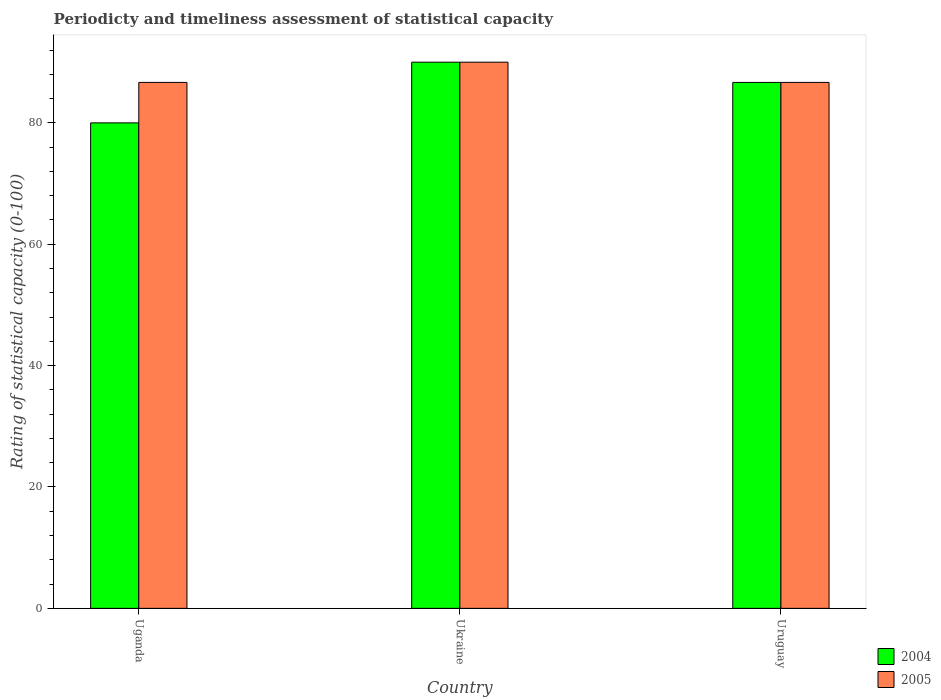Are the number of bars per tick equal to the number of legend labels?
Offer a very short reply. Yes. Are the number of bars on each tick of the X-axis equal?
Provide a succinct answer. Yes. How many bars are there on the 3rd tick from the right?
Offer a very short reply. 2. What is the label of the 1st group of bars from the left?
Ensure brevity in your answer.  Uganda. In how many cases, is the number of bars for a given country not equal to the number of legend labels?
Your answer should be compact. 0. What is the rating of statistical capacity in 2005 in Ukraine?
Your response must be concise. 90. Across all countries, what is the maximum rating of statistical capacity in 2004?
Provide a short and direct response. 90. In which country was the rating of statistical capacity in 2005 maximum?
Your answer should be very brief. Ukraine. In which country was the rating of statistical capacity in 2005 minimum?
Ensure brevity in your answer.  Uganda. What is the total rating of statistical capacity in 2004 in the graph?
Offer a terse response. 256.67. What is the difference between the rating of statistical capacity in 2005 in Uganda and that in Ukraine?
Your response must be concise. -3.33. What is the difference between the rating of statistical capacity in 2005 in Uganda and the rating of statistical capacity in 2004 in Uruguay?
Make the answer very short. 0. What is the average rating of statistical capacity in 2004 per country?
Provide a short and direct response. 85.56. What is the difference between the rating of statistical capacity of/in 2004 and rating of statistical capacity of/in 2005 in Uruguay?
Offer a terse response. 0. What is the ratio of the rating of statistical capacity in 2005 in Uganda to that in Ukraine?
Your answer should be compact. 0.96. What is the difference between the highest and the second highest rating of statistical capacity in 2004?
Your answer should be compact. -10. What is the difference between the highest and the lowest rating of statistical capacity in 2005?
Your answer should be very brief. 3.33. Is the sum of the rating of statistical capacity in 2004 in Uganda and Ukraine greater than the maximum rating of statistical capacity in 2005 across all countries?
Provide a succinct answer. Yes. What does the 2nd bar from the right in Uruguay represents?
Keep it short and to the point. 2004. How many bars are there?
Provide a short and direct response. 6. How many countries are there in the graph?
Give a very brief answer. 3. Where does the legend appear in the graph?
Give a very brief answer. Bottom right. How many legend labels are there?
Give a very brief answer. 2. How are the legend labels stacked?
Keep it short and to the point. Vertical. What is the title of the graph?
Keep it short and to the point. Periodicty and timeliness assessment of statistical capacity. Does "2000" appear as one of the legend labels in the graph?
Ensure brevity in your answer.  No. What is the label or title of the Y-axis?
Keep it short and to the point. Rating of statistical capacity (0-100). What is the Rating of statistical capacity (0-100) of 2004 in Uganda?
Offer a terse response. 80. What is the Rating of statistical capacity (0-100) of 2005 in Uganda?
Your answer should be very brief. 86.67. What is the Rating of statistical capacity (0-100) in 2005 in Ukraine?
Ensure brevity in your answer.  90. What is the Rating of statistical capacity (0-100) of 2004 in Uruguay?
Ensure brevity in your answer.  86.67. What is the Rating of statistical capacity (0-100) of 2005 in Uruguay?
Your answer should be compact. 86.67. Across all countries, what is the maximum Rating of statistical capacity (0-100) in 2004?
Give a very brief answer. 90. Across all countries, what is the maximum Rating of statistical capacity (0-100) of 2005?
Offer a very short reply. 90. Across all countries, what is the minimum Rating of statistical capacity (0-100) of 2005?
Your answer should be compact. 86.67. What is the total Rating of statistical capacity (0-100) in 2004 in the graph?
Your answer should be compact. 256.67. What is the total Rating of statistical capacity (0-100) in 2005 in the graph?
Provide a short and direct response. 263.33. What is the difference between the Rating of statistical capacity (0-100) in 2005 in Uganda and that in Ukraine?
Offer a terse response. -3.33. What is the difference between the Rating of statistical capacity (0-100) of 2004 in Uganda and that in Uruguay?
Ensure brevity in your answer.  -6.67. What is the difference between the Rating of statistical capacity (0-100) of 2005 in Uganda and that in Uruguay?
Offer a very short reply. 0. What is the difference between the Rating of statistical capacity (0-100) of 2004 in Ukraine and that in Uruguay?
Your answer should be compact. 3.33. What is the difference between the Rating of statistical capacity (0-100) in 2005 in Ukraine and that in Uruguay?
Keep it short and to the point. 3.33. What is the difference between the Rating of statistical capacity (0-100) in 2004 in Uganda and the Rating of statistical capacity (0-100) in 2005 in Uruguay?
Ensure brevity in your answer.  -6.67. What is the average Rating of statistical capacity (0-100) of 2004 per country?
Provide a short and direct response. 85.56. What is the average Rating of statistical capacity (0-100) of 2005 per country?
Give a very brief answer. 87.78. What is the difference between the Rating of statistical capacity (0-100) in 2004 and Rating of statistical capacity (0-100) in 2005 in Uganda?
Make the answer very short. -6.67. What is the ratio of the Rating of statistical capacity (0-100) of 2004 in Uganda to that in Ukraine?
Make the answer very short. 0.89. What is the ratio of the Rating of statistical capacity (0-100) of 2004 in Uganda to that in Uruguay?
Offer a terse response. 0.92. 